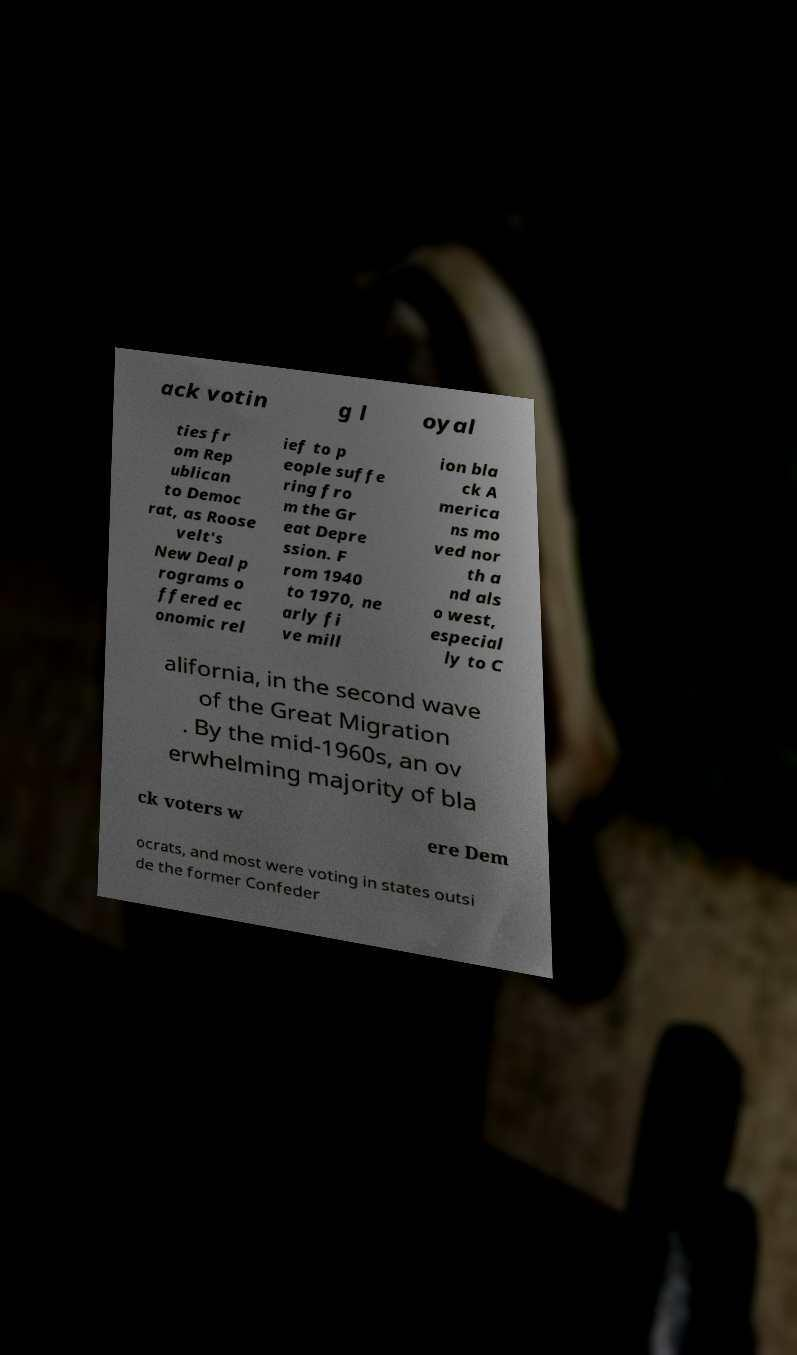I need the written content from this picture converted into text. Can you do that? ack votin g l oyal ties fr om Rep ublican to Democ rat, as Roose velt's New Deal p rograms o ffered ec onomic rel ief to p eople suffe ring fro m the Gr eat Depre ssion. F rom 1940 to 1970, ne arly fi ve mill ion bla ck A merica ns mo ved nor th a nd als o west, especial ly to C alifornia, in the second wave of the Great Migration . By the mid-1960s, an ov erwhelming majority of bla ck voters w ere Dem ocrats, and most were voting in states outsi de the former Confeder 